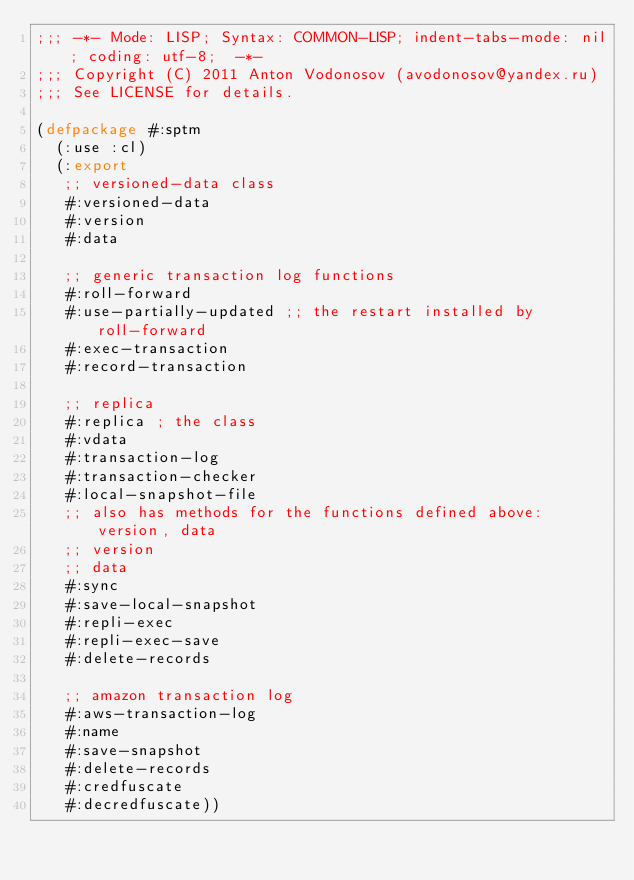Convert code to text. <code><loc_0><loc_0><loc_500><loc_500><_Lisp_>;;; -*- Mode: LISP; Syntax: COMMON-LISP; indent-tabs-mode: nil; coding: utf-8;  -*-
;;; Copyright (C) 2011 Anton Vodonosov (avodonosov@yandex.ru)
;;; See LICENSE for details.

(defpackage #:sptm
  (:use :cl)
  (:export
   ;; versioned-data class
   #:versioned-data
   #:version
   #:data

   ;; generic transaction log functions
   #:roll-forward
   #:use-partially-updated ;; the restart installed by roll-forward
   #:exec-transaction
   #:record-transaction

   ;; replica
   #:replica ; the class
   #:vdata
   #:transaction-log
   #:transaction-checker
   #:local-snapshot-file
   ;; also has methods for the functions defined above: version, data
   ;; version
   ;; data
   #:sync
   #:save-local-snapshot
   #:repli-exec
   #:repli-exec-save
   #:delete-records

   ;; amazon transaction log
   #:aws-transaction-log
   #:name
   #:save-snapshot
   #:delete-records
   #:credfuscate
   #:decredfuscate))
</code> 